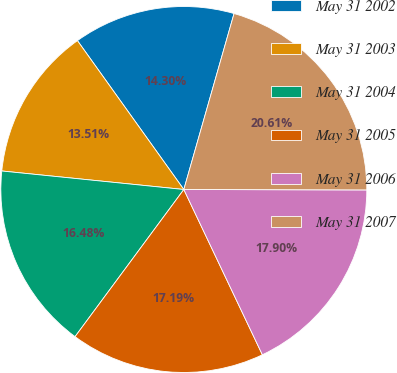Convert chart. <chart><loc_0><loc_0><loc_500><loc_500><pie_chart><fcel>May 31 2002<fcel>May 31 2003<fcel>May 31 2004<fcel>May 31 2005<fcel>May 31 2006<fcel>May 31 2007<nl><fcel>14.3%<fcel>13.51%<fcel>16.48%<fcel>17.19%<fcel>17.9%<fcel>20.61%<nl></chart> 